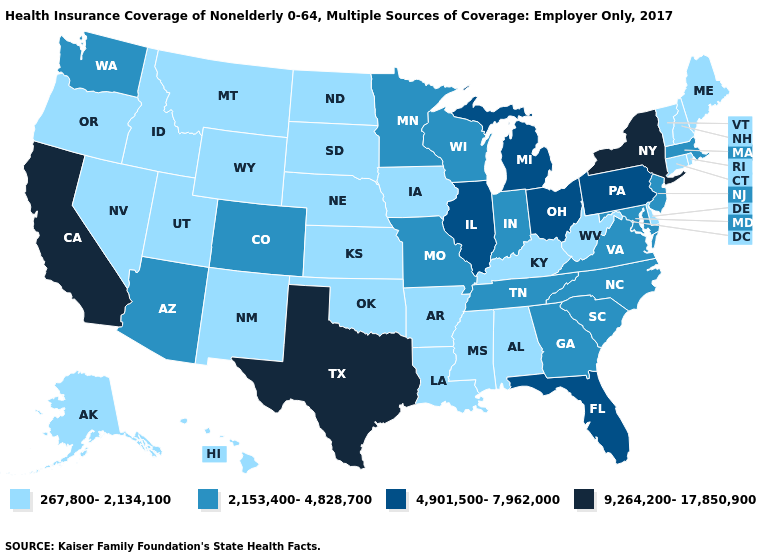Name the states that have a value in the range 9,264,200-17,850,900?
Keep it brief. California, New York, Texas. What is the value of Texas?
Give a very brief answer. 9,264,200-17,850,900. What is the value of Oklahoma?
Keep it brief. 267,800-2,134,100. What is the lowest value in states that border Iowa?
Write a very short answer. 267,800-2,134,100. Which states hav the highest value in the Northeast?
Answer briefly. New York. Name the states that have a value in the range 2,153,400-4,828,700?
Answer briefly. Arizona, Colorado, Georgia, Indiana, Maryland, Massachusetts, Minnesota, Missouri, New Jersey, North Carolina, South Carolina, Tennessee, Virginia, Washington, Wisconsin. How many symbols are there in the legend?
Concise answer only. 4. Name the states that have a value in the range 2,153,400-4,828,700?
Write a very short answer. Arizona, Colorado, Georgia, Indiana, Maryland, Massachusetts, Minnesota, Missouri, New Jersey, North Carolina, South Carolina, Tennessee, Virginia, Washington, Wisconsin. Which states have the highest value in the USA?
Write a very short answer. California, New York, Texas. Name the states that have a value in the range 2,153,400-4,828,700?
Quick response, please. Arizona, Colorado, Georgia, Indiana, Maryland, Massachusetts, Minnesota, Missouri, New Jersey, North Carolina, South Carolina, Tennessee, Virginia, Washington, Wisconsin. What is the highest value in states that border Delaware?
Be succinct. 4,901,500-7,962,000. What is the highest value in the USA?
Write a very short answer. 9,264,200-17,850,900. Does New York have a higher value than California?
Write a very short answer. No. How many symbols are there in the legend?
Give a very brief answer. 4. Among the states that border North Carolina , which have the lowest value?
Be succinct. Georgia, South Carolina, Tennessee, Virginia. 